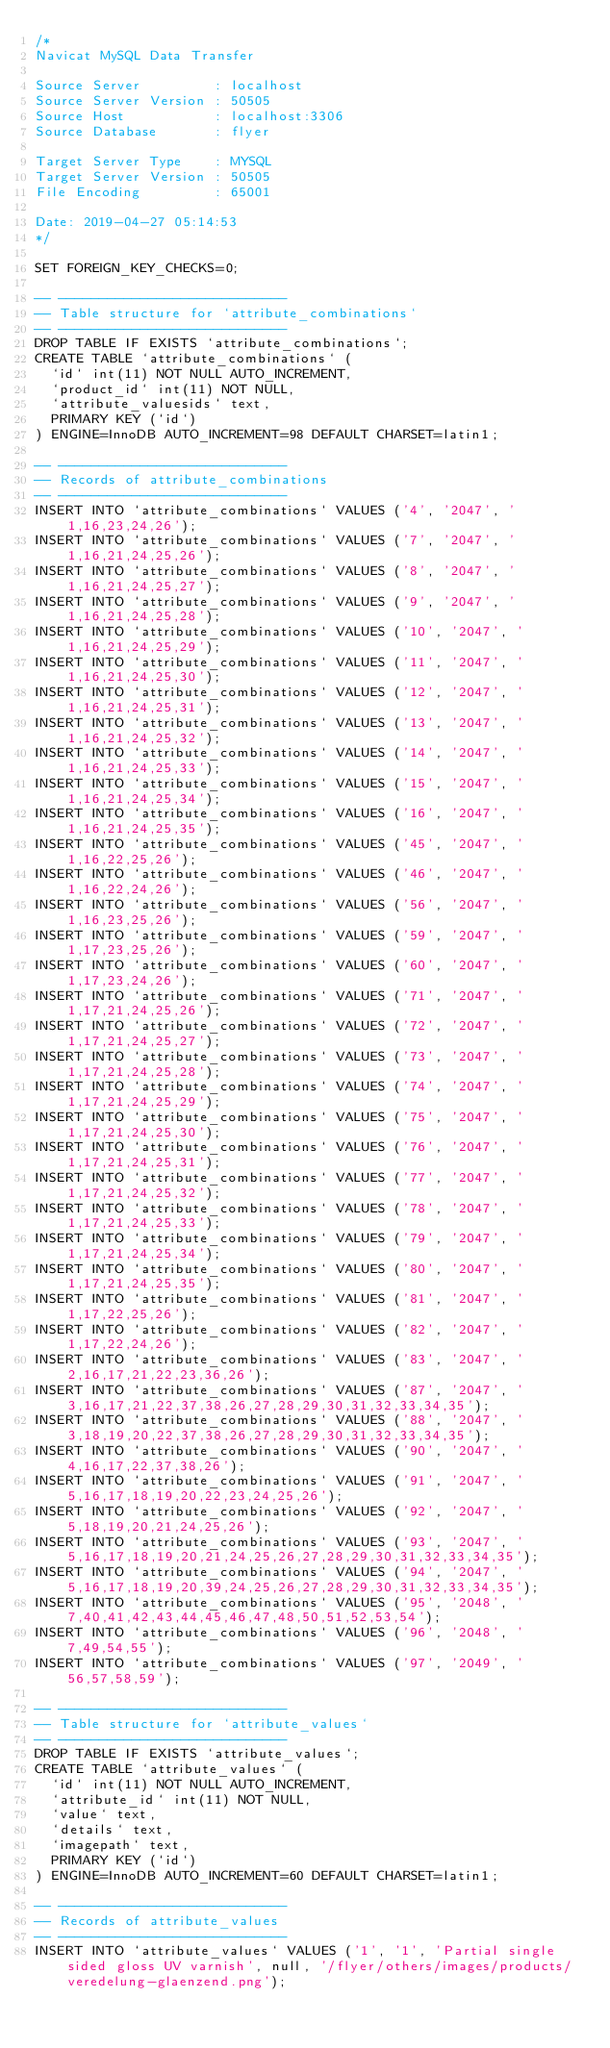Convert code to text. <code><loc_0><loc_0><loc_500><loc_500><_SQL_>/*
Navicat MySQL Data Transfer

Source Server         : localhost
Source Server Version : 50505
Source Host           : localhost:3306
Source Database       : flyer

Target Server Type    : MYSQL
Target Server Version : 50505
File Encoding         : 65001

Date: 2019-04-27 05:14:53
*/

SET FOREIGN_KEY_CHECKS=0;

-- ----------------------------
-- Table structure for `attribute_combinations`
-- ----------------------------
DROP TABLE IF EXISTS `attribute_combinations`;
CREATE TABLE `attribute_combinations` (
  `id` int(11) NOT NULL AUTO_INCREMENT,
  `product_id` int(11) NOT NULL,
  `attribute_valuesids` text,
  PRIMARY KEY (`id`)
) ENGINE=InnoDB AUTO_INCREMENT=98 DEFAULT CHARSET=latin1;

-- ----------------------------
-- Records of attribute_combinations
-- ----------------------------
INSERT INTO `attribute_combinations` VALUES ('4', '2047', '1,16,23,24,26');
INSERT INTO `attribute_combinations` VALUES ('7', '2047', '1,16,21,24,25,26');
INSERT INTO `attribute_combinations` VALUES ('8', '2047', '1,16,21,24,25,27');
INSERT INTO `attribute_combinations` VALUES ('9', '2047', '1,16,21,24,25,28');
INSERT INTO `attribute_combinations` VALUES ('10', '2047', '1,16,21,24,25,29');
INSERT INTO `attribute_combinations` VALUES ('11', '2047', '1,16,21,24,25,30');
INSERT INTO `attribute_combinations` VALUES ('12', '2047', '1,16,21,24,25,31');
INSERT INTO `attribute_combinations` VALUES ('13', '2047', '1,16,21,24,25,32');
INSERT INTO `attribute_combinations` VALUES ('14', '2047', '1,16,21,24,25,33');
INSERT INTO `attribute_combinations` VALUES ('15', '2047', '1,16,21,24,25,34');
INSERT INTO `attribute_combinations` VALUES ('16', '2047', '1,16,21,24,25,35');
INSERT INTO `attribute_combinations` VALUES ('45', '2047', '1,16,22,25,26');
INSERT INTO `attribute_combinations` VALUES ('46', '2047', '1,16,22,24,26');
INSERT INTO `attribute_combinations` VALUES ('56', '2047', '1,16,23,25,26');
INSERT INTO `attribute_combinations` VALUES ('59', '2047', '1,17,23,25,26');
INSERT INTO `attribute_combinations` VALUES ('60', '2047', '1,17,23,24,26');
INSERT INTO `attribute_combinations` VALUES ('71', '2047', '1,17,21,24,25,26');
INSERT INTO `attribute_combinations` VALUES ('72', '2047', '1,17,21,24,25,27');
INSERT INTO `attribute_combinations` VALUES ('73', '2047', '1,17,21,24,25,28');
INSERT INTO `attribute_combinations` VALUES ('74', '2047', '1,17,21,24,25,29');
INSERT INTO `attribute_combinations` VALUES ('75', '2047', '1,17,21,24,25,30');
INSERT INTO `attribute_combinations` VALUES ('76', '2047', '1,17,21,24,25,31');
INSERT INTO `attribute_combinations` VALUES ('77', '2047', '1,17,21,24,25,32');
INSERT INTO `attribute_combinations` VALUES ('78', '2047', '1,17,21,24,25,33');
INSERT INTO `attribute_combinations` VALUES ('79', '2047', '1,17,21,24,25,34');
INSERT INTO `attribute_combinations` VALUES ('80', '2047', '1,17,21,24,25,35');
INSERT INTO `attribute_combinations` VALUES ('81', '2047', '1,17,22,25,26');
INSERT INTO `attribute_combinations` VALUES ('82', '2047', '1,17,22,24,26');
INSERT INTO `attribute_combinations` VALUES ('83', '2047', '2,16,17,21,22,23,36,26');
INSERT INTO `attribute_combinations` VALUES ('87', '2047', '3,16,17,21,22,37,38,26,27,28,29,30,31,32,33,34,35');
INSERT INTO `attribute_combinations` VALUES ('88', '2047', '3,18,19,20,22,37,38,26,27,28,29,30,31,32,33,34,35');
INSERT INTO `attribute_combinations` VALUES ('90', '2047', '4,16,17,22,37,38,26');
INSERT INTO `attribute_combinations` VALUES ('91', '2047', '5,16,17,18,19,20,22,23,24,25,26');
INSERT INTO `attribute_combinations` VALUES ('92', '2047', '5,18,19,20,21,24,25,26');
INSERT INTO `attribute_combinations` VALUES ('93', '2047', '5,16,17,18,19,20,21,24,25,26,27,28,29,30,31,32,33,34,35');
INSERT INTO `attribute_combinations` VALUES ('94', '2047', '5,16,17,18,19,20,39,24,25,26,27,28,29,30,31,32,33,34,35');
INSERT INTO `attribute_combinations` VALUES ('95', '2048', '7,40,41,42,43,44,45,46,47,48,50,51,52,53,54');
INSERT INTO `attribute_combinations` VALUES ('96', '2048', '7,49,54,55');
INSERT INTO `attribute_combinations` VALUES ('97', '2049', '56,57,58,59');

-- ----------------------------
-- Table structure for `attribute_values`
-- ----------------------------
DROP TABLE IF EXISTS `attribute_values`;
CREATE TABLE `attribute_values` (
  `id` int(11) NOT NULL AUTO_INCREMENT,
  `attribute_id` int(11) NOT NULL,
  `value` text,
  `details` text,
  `imagepath` text,
  PRIMARY KEY (`id`)
) ENGINE=InnoDB AUTO_INCREMENT=60 DEFAULT CHARSET=latin1;

-- ----------------------------
-- Records of attribute_values
-- ----------------------------
INSERT INTO `attribute_values` VALUES ('1', '1', 'Partial single sided gloss UV varnish', null, '/flyer/others/images/products/veredelung-glaenzend.png');</code> 